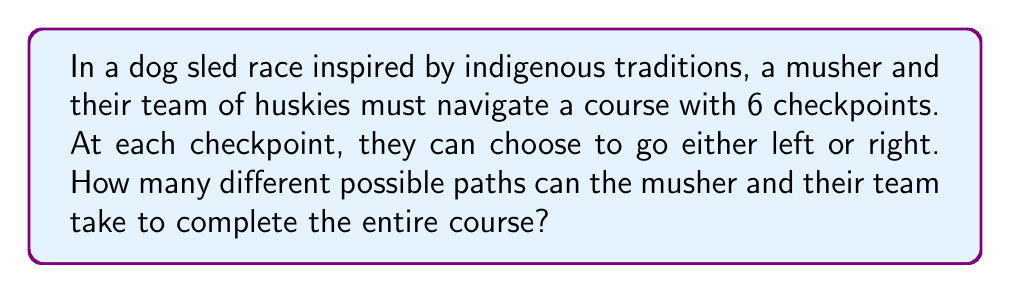Give your solution to this math problem. Let's approach this step-by-step:

1) At each checkpoint, the musher has two choices: left or right.

2) There are 6 checkpoints in total, and at each one, a choice must be made.

3) This scenario can be modeled using the multiplication principle of counting. When we have a sequence of independent choices, we multiply the number of options for each choice.

4) In this case, we have:
   - 2 choices for the 1st checkpoint
   - 2 choices for the 2nd checkpoint
   - 2 choices for the 3rd checkpoint
   - 2 choices for the 4th checkpoint
   - 2 choices for the 5th checkpoint
   - 2 choices for the 6th checkpoint

5) Therefore, the total number of possible paths is:

   $$ 2 \times 2 \times 2 \times 2 \times 2 \times 2 = 2^6 $$

6) We can calculate this:

   $$ 2^6 = 64 $$

Thus, there are 64 different possible paths for the musher and their team of huskies to complete the course.
Answer: 64 